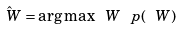Convert formula to latex. <formula><loc_0><loc_0><loc_500><loc_500>\hat { \ W } = \arg \max { \ W } \ p ( \ W )</formula> 